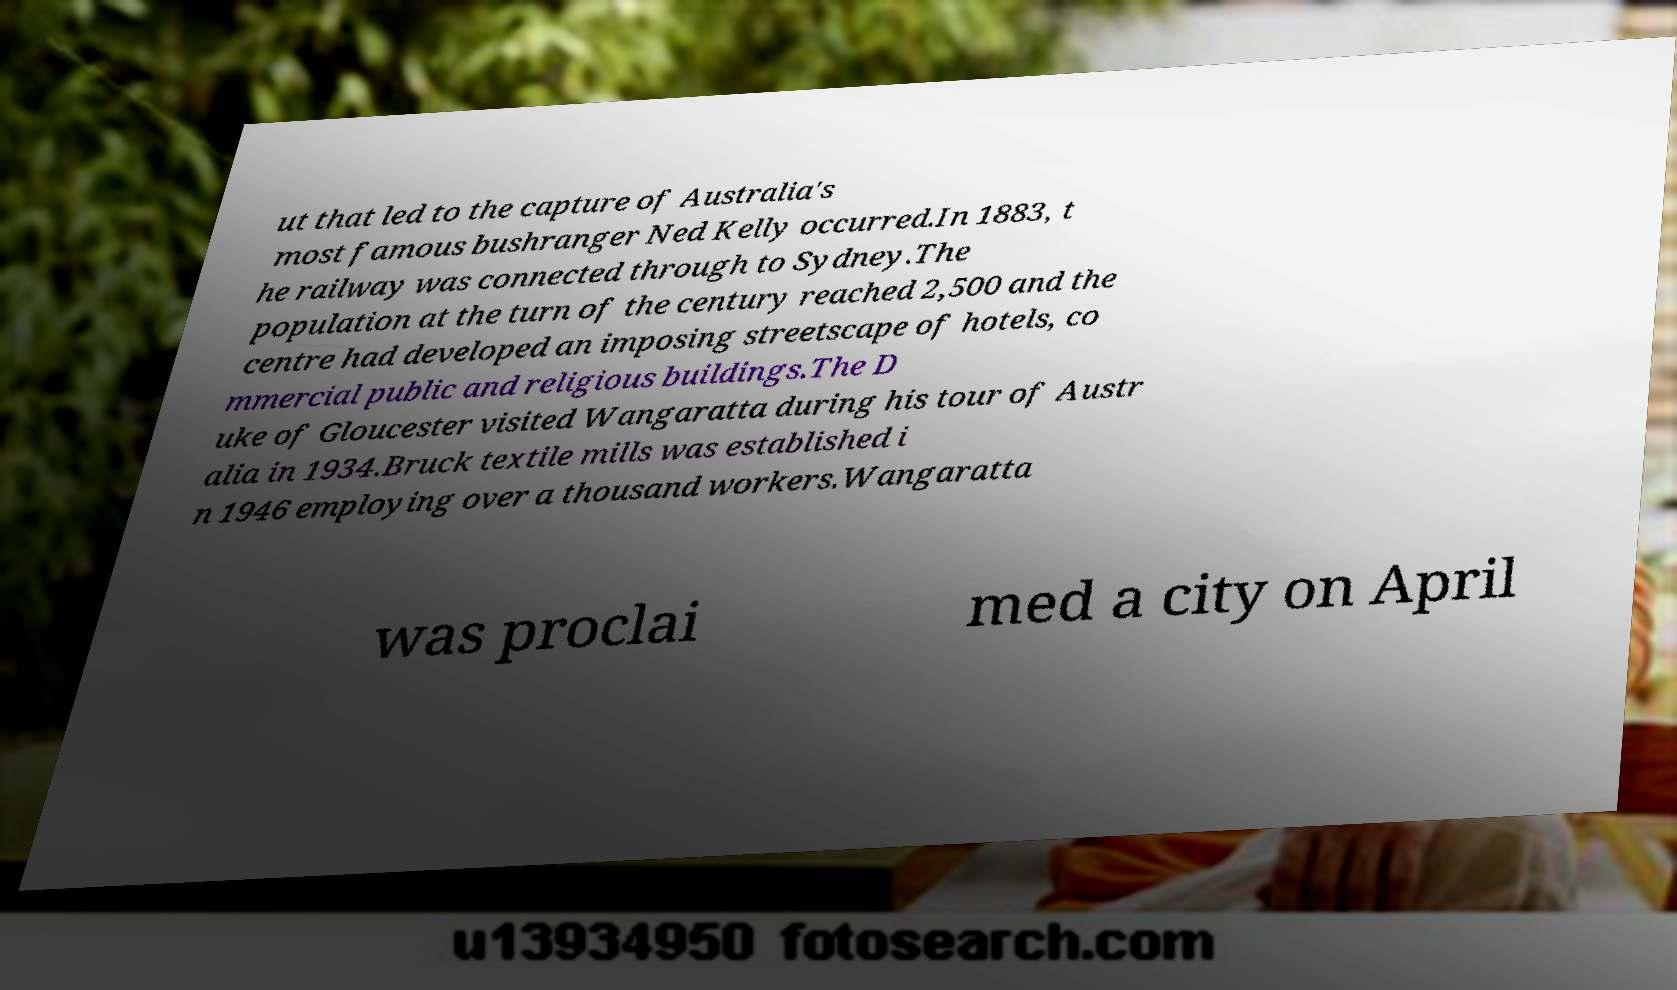Can you read and provide the text displayed in the image?This photo seems to have some interesting text. Can you extract and type it out for me? ut that led to the capture of Australia's most famous bushranger Ned Kelly occurred.In 1883, t he railway was connected through to Sydney.The population at the turn of the century reached 2,500 and the centre had developed an imposing streetscape of hotels, co mmercial public and religious buildings.The D uke of Gloucester visited Wangaratta during his tour of Austr alia in 1934.Bruck textile mills was established i n 1946 employing over a thousand workers.Wangaratta was proclai med a city on April 